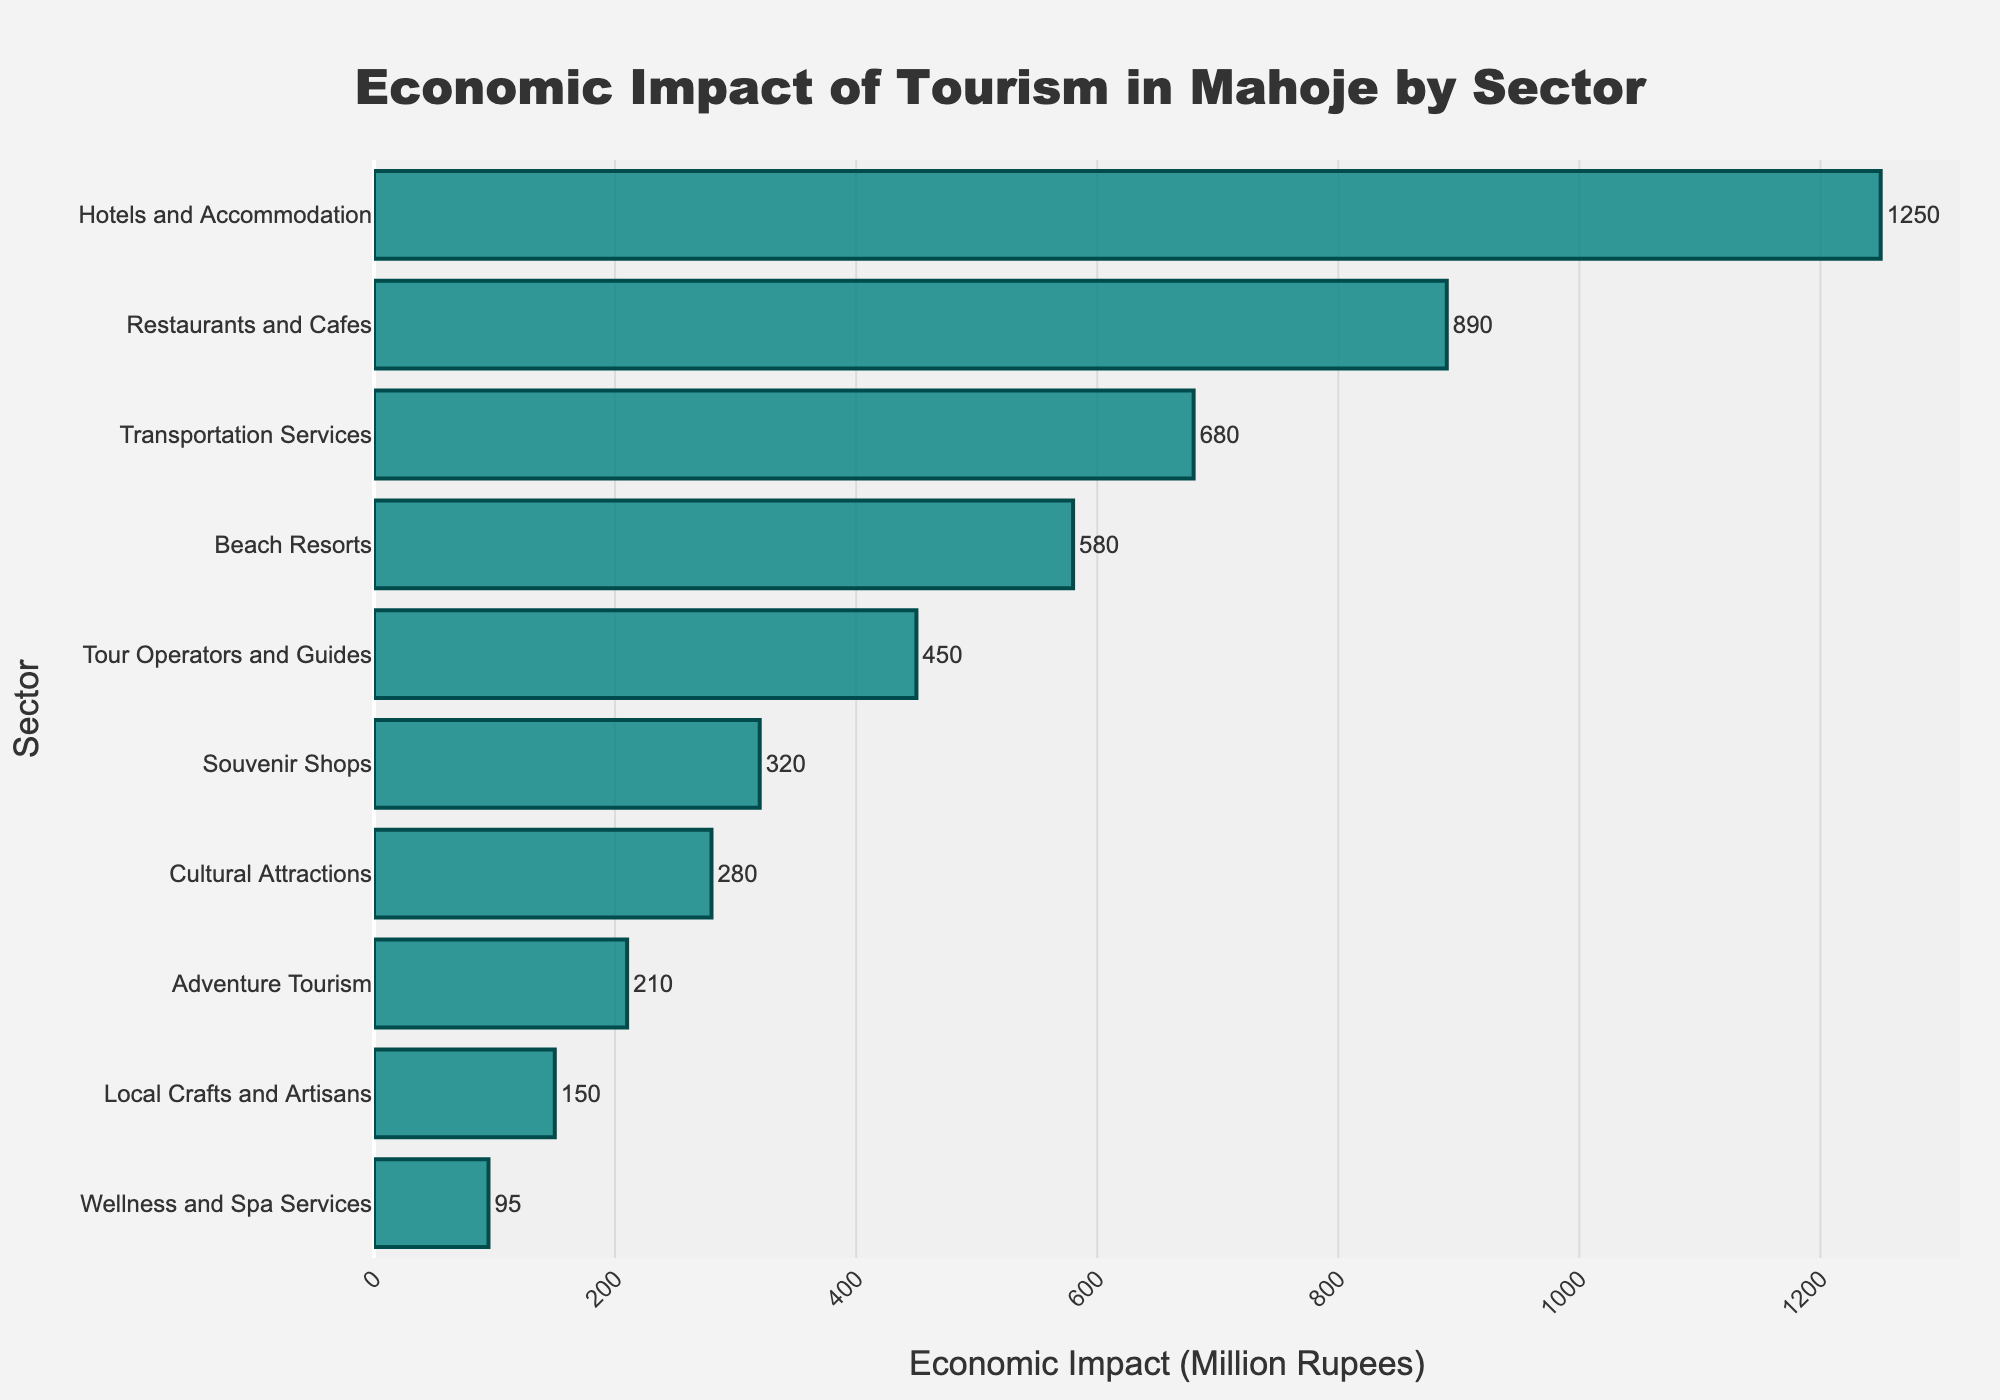What is the sector with the highest economic impact from tourism? By examining the figure, we see that the longest bar, representing the highest economic impact, corresponds to the "Hotels and Accommodation" sector with an economic impact of 1250 million rupees.
Answer: Hotels and Accommodation Which sector has a greater economic impact: Beach Resorts or Restaurants and Cafes? Comparing the lengths of the bars for these two sectors, we see that Beach Resorts have a shorter bar (580 million rupees) than Restaurants and Cafes (890 million rupees). Therefore, Restaurants and Cafes have a greater economic impact.
Answer: Restaurants and Cafes How much greater is the economic impact of Transportation Services compared to Wellness and Spa Services? The economic impact of Transportation Services is 680 million rupees, while Wellness and Spa Services have an impact of 95 million rupees. The difference is calculated as 680 - 95 = 585 million rupees.
Answer: 585 million rupees What is the total economic impact of the sectors other than Hotels and Accommodation and Restaurants and Cafes? First, sum the economic impacts of all sectors except Hotels and Accommodation and Restaurants and Cafes: 680 + 450 + 320 + 280 + 210 + 580 + 150 + 95 = 2765 million rupees.
Answer: 2765 million rupees Which sector has the least economic impact from tourism? Looking at the shortest bar in the figure, Wellness and Spa Services have the least economic impact, with 95 million rupees.
Answer: Wellness and Spa Services Which two sectors combined have an equal or almost equal economic impact to Transportation Services? Transportation Services have an impact of 680 million rupees. Cultural Attractions (280 million rupees) and Beach Resorts (580 million rupees) together have a sum of 280 + 580 = 860 million rupees, which is the closest combination to the economic impact of Transportation Services.
Answer: Cultural Attractions and Beach Resorts What is the average economic impact of the sectors shown in the figure? To find the average, sum all economic impacts: 1250 + 890 + 680 + 450 + 320 + 280 + 210 + 580 + 150 + 95 = 4905 million rupees. Divide by the number of sectors (10): 4905 / 10 = 490.5 million rupees.
Answer: 490.5 million rupees Which sector has an economic impact closest to 500 million rupees? Among the sectors, Beach Resorts have an economic impact of 580 million rupees, which is the closest to 500 million rupees.
Answer: Beach Resorts 